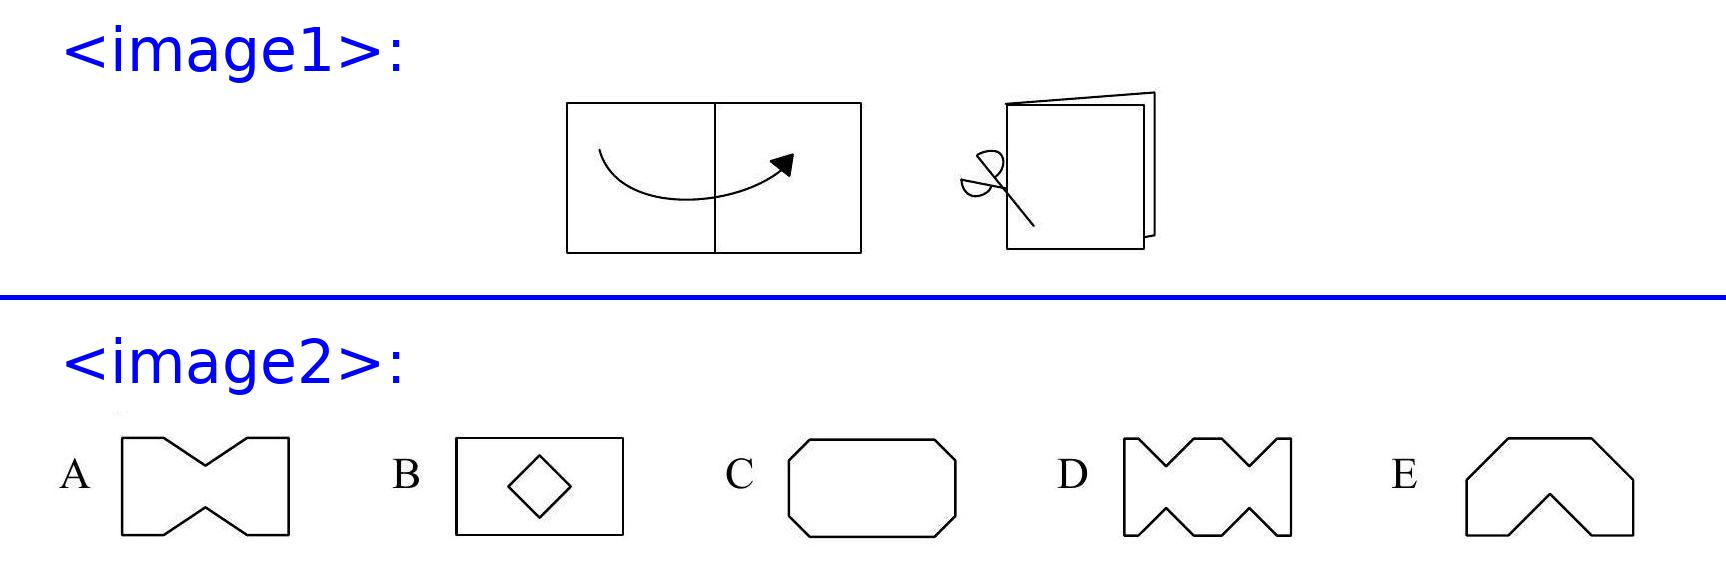Werner folds a sheet of paper as shown in the diagram and makes two straight cuts with a pair of scissors. He then opens up the paper again. Which of the following shapes cannot be the result? <image2> Choices: ['A', 'B', 'C', 'D', 'E'] Answer is D. 